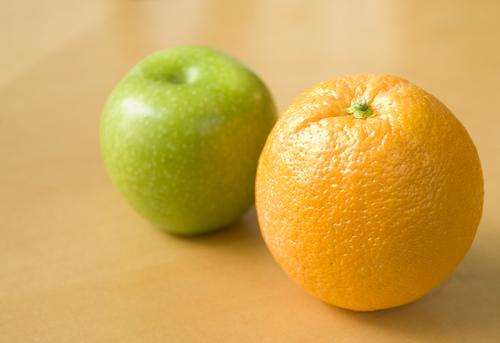Is one of the fruits sour?
Answer briefly. No. Which fruit has dark colored seeds inside?
Write a very short answer. Apple. What color is the fruit in the front?
Write a very short answer. Orange. 